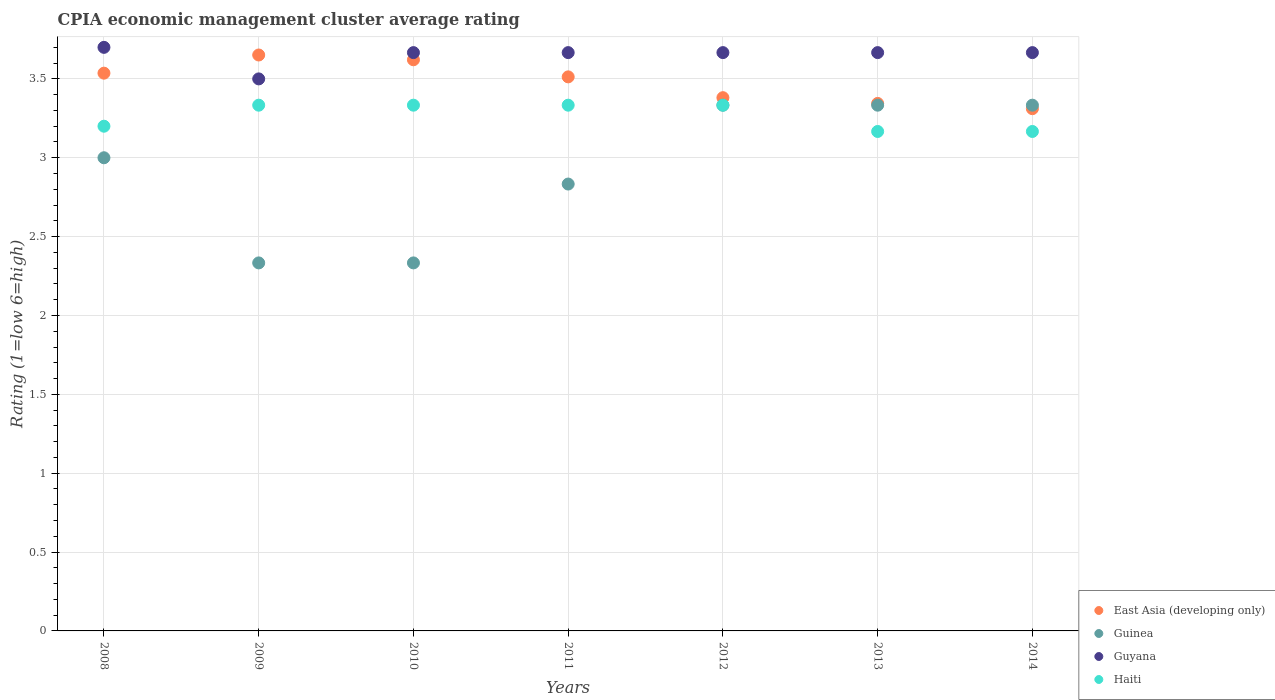What is the CPIA rating in Guyana in 2010?
Your response must be concise. 3.67. Across all years, what is the maximum CPIA rating in East Asia (developing only)?
Provide a succinct answer. 3.65. Across all years, what is the minimum CPIA rating in Haiti?
Give a very brief answer. 3.17. In which year was the CPIA rating in Haiti minimum?
Keep it short and to the point. 2013. What is the total CPIA rating in Guinea in the graph?
Provide a short and direct response. 20.5. What is the difference between the CPIA rating in Guyana in 2008 and that in 2011?
Make the answer very short. 0.03. What is the difference between the CPIA rating in Guinea in 2011 and the CPIA rating in East Asia (developing only) in 2012?
Your answer should be very brief. -0.55. What is the average CPIA rating in East Asia (developing only) per year?
Provide a short and direct response. 3.48. In the year 2008, what is the difference between the CPIA rating in Guyana and CPIA rating in East Asia (developing only)?
Offer a very short reply. 0.16. What is the ratio of the CPIA rating in East Asia (developing only) in 2008 to that in 2011?
Make the answer very short. 1.01. What is the difference between the highest and the second highest CPIA rating in Guyana?
Your response must be concise. 0.03. What is the difference between the highest and the lowest CPIA rating in East Asia (developing only)?
Provide a short and direct response. 0.34. In how many years, is the CPIA rating in Guyana greater than the average CPIA rating in Guyana taken over all years?
Ensure brevity in your answer.  6. Is the CPIA rating in Haiti strictly less than the CPIA rating in East Asia (developing only) over the years?
Your response must be concise. Yes. How many dotlines are there?
Provide a succinct answer. 4. How many years are there in the graph?
Make the answer very short. 7. What is the difference between two consecutive major ticks on the Y-axis?
Offer a terse response. 0.5. Does the graph contain any zero values?
Keep it short and to the point. No. Where does the legend appear in the graph?
Provide a short and direct response. Bottom right. How many legend labels are there?
Offer a very short reply. 4. How are the legend labels stacked?
Offer a terse response. Vertical. What is the title of the graph?
Your response must be concise. CPIA economic management cluster average rating. What is the label or title of the X-axis?
Give a very brief answer. Years. What is the label or title of the Y-axis?
Your response must be concise. Rating (1=low 6=high). What is the Rating (1=low 6=high) of East Asia (developing only) in 2008?
Make the answer very short. 3.54. What is the Rating (1=low 6=high) in Guinea in 2008?
Give a very brief answer. 3. What is the Rating (1=low 6=high) in East Asia (developing only) in 2009?
Make the answer very short. 3.65. What is the Rating (1=low 6=high) in Guinea in 2009?
Your answer should be compact. 2.33. What is the Rating (1=low 6=high) in Haiti in 2009?
Provide a short and direct response. 3.33. What is the Rating (1=low 6=high) of East Asia (developing only) in 2010?
Keep it short and to the point. 3.62. What is the Rating (1=low 6=high) in Guinea in 2010?
Provide a short and direct response. 2.33. What is the Rating (1=low 6=high) in Guyana in 2010?
Offer a terse response. 3.67. What is the Rating (1=low 6=high) of Haiti in 2010?
Offer a terse response. 3.33. What is the Rating (1=low 6=high) of East Asia (developing only) in 2011?
Provide a short and direct response. 3.51. What is the Rating (1=low 6=high) in Guinea in 2011?
Your response must be concise. 2.83. What is the Rating (1=low 6=high) in Guyana in 2011?
Ensure brevity in your answer.  3.67. What is the Rating (1=low 6=high) in Haiti in 2011?
Provide a short and direct response. 3.33. What is the Rating (1=low 6=high) in East Asia (developing only) in 2012?
Your answer should be compact. 3.38. What is the Rating (1=low 6=high) of Guinea in 2012?
Offer a very short reply. 3.33. What is the Rating (1=low 6=high) of Guyana in 2012?
Give a very brief answer. 3.67. What is the Rating (1=low 6=high) of Haiti in 2012?
Provide a succinct answer. 3.33. What is the Rating (1=low 6=high) of East Asia (developing only) in 2013?
Your answer should be compact. 3.34. What is the Rating (1=low 6=high) in Guinea in 2013?
Give a very brief answer. 3.33. What is the Rating (1=low 6=high) in Guyana in 2013?
Your answer should be very brief. 3.67. What is the Rating (1=low 6=high) of Haiti in 2013?
Your answer should be compact. 3.17. What is the Rating (1=low 6=high) in East Asia (developing only) in 2014?
Keep it short and to the point. 3.31. What is the Rating (1=low 6=high) of Guinea in 2014?
Your answer should be very brief. 3.33. What is the Rating (1=low 6=high) in Guyana in 2014?
Your answer should be very brief. 3.67. What is the Rating (1=low 6=high) of Haiti in 2014?
Your answer should be compact. 3.17. Across all years, what is the maximum Rating (1=low 6=high) of East Asia (developing only)?
Offer a very short reply. 3.65. Across all years, what is the maximum Rating (1=low 6=high) in Guinea?
Provide a succinct answer. 3.33. Across all years, what is the maximum Rating (1=low 6=high) in Guyana?
Provide a short and direct response. 3.7. Across all years, what is the maximum Rating (1=low 6=high) of Haiti?
Keep it short and to the point. 3.33. Across all years, what is the minimum Rating (1=low 6=high) in East Asia (developing only)?
Offer a terse response. 3.31. Across all years, what is the minimum Rating (1=low 6=high) of Guinea?
Keep it short and to the point. 2.33. Across all years, what is the minimum Rating (1=low 6=high) of Haiti?
Provide a succinct answer. 3.17. What is the total Rating (1=low 6=high) of East Asia (developing only) in the graph?
Give a very brief answer. 24.36. What is the total Rating (1=low 6=high) in Guyana in the graph?
Make the answer very short. 25.53. What is the total Rating (1=low 6=high) of Haiti in the graph?
Offer a terse response. 22.87. What is the difference between the Rating (1=low 6=high) of East Asia (developing only) in 2008 and that in 2009?
Provide a succinct answer. -0.12. What is the difference between the Rating (1=low 6=high) in Guinea in 2008 and that in 2009?
Give a very brief answer. 0.67. What is the difference between the Rating (1=low 6=high) of Guyana in 2008 and that in 2009?
Provide a short and direct response. 0.2. What is the difference between the Rating (1=low 6=high) in Haiti in 2008 and that in 2009?
Give a very brief answer. -0.13. What is the difference between the Rating (1=low 6=high) of East Asia (developing only) in 2008 and that in 2010?
Ensure brevity in your answer.  -0.08. What is the difference between the Rating (1=low 6=high) of Guinea in 2008 and that in 2010?
Provide a short and direct response. 0.67. What is the difference between the Rating (1=low 6=high) in Haiti in 2008 and that in 2010?
Your response must be concise. -0.13. What is the difference between the Rating (1=low 6=high) of East Asia (developing only) in 2008 and that in 2011?
Offer a terse response. 0.02. What is the difference between the Rating (1=low 6=high) in Haiti in 2008 and that in 2011?
Offer a very short reply. -0.13. What is the difference between the Rating (1=low 6=high) in East Asia (developing only) in 2008 and that in 2012?
Provide a succinct answer. 0.16. What is the difference between the Rating (1=low 6=high) of Guinea in 2008 and that in 2012?
Provide a short and direct response. -0.33. What is the difference between the Rating (1=low 6=high) in Haiti in 2008 and that in 2012?
Provide a succinct answer. -0.13. What is the difference between the Rating (1=low 6=high) of East Asia (developing only) in 2008 and that in 2013?
Your answer should be compact. 0.19. What is the difference between the Rating (1=low 6=high) of East Asia (developing only) in 2008 and that in 2014?
Keep it short and to the point. 0.23. What is the difference between the Rating (1=low 6=high) of Guyana in 2008 and that in 2014?
Your answer should be very brief. 0.03. What is the difference between the Rating (1=low 6=high) in Haiti in 2008 and that in 2014?
Ensure brevity in your answer.  0.03. What is the difference between the Rating (1=low 6=high) of East Asia (developing only) in 2009 and that in 2010?
Your answer should be very brief. 0.03. What is the difference between the Rating (1=low 6=high) of Guyana in 2009 and that in 2010?
Make the answer very short. -0.17. What is the difference between the Rating (1=low 6=high) of East Asia (developing only) in 2009 and that in 2011?
Keep it short and to the point. 0.14. What is the difference between the Rating (1=low 6=high) of Guinea in 2009 and that in 2011?
Your answer should be very brief. -0.5. What is the difference between the Rating (1=low 6=high) of East Asia (developing only) in 2009 and that in 2012?
Your answer should be compact. 0.27. What is the difference between the Rating (1=low 6=high) of Haiti in 2009 and that in 2012?
Ensure brevity in your answer.  0. What is the difference between the Rating (1=low 6=high) in East Asia (developing only) in 2009 and that in 2013?
Provide a short and direct response. 0.31. What is the difference between the Rating (1=low 6=high) of Guinea in 2009 and that in 2013?
Offer a very short reply. -1. What is the difference between the Rating (1=low 6=high) of Guyana in 2009 and that in 2013?
Your answer should be compact. -0.17. What is the difference between the Rating (1=low 6=high) of East Asia (developing only) in 2009 and that in 2014?
Offer a very short reply. 0.34. What is the difference between the Rating (1=low 6=high) of Guinea in 2009 and that in 2014?
Make the answer very short. -1. What is the difference between the Rating (1=low 6=high) in Haiti in 2009 and that in 2014?
Offer a very short reply. 0.17. What is the difference between the Rating (1=low 6=high) of East Asia (developing only) in 2010 and that in 2011?
Provide a succinct answer. 0.11. What is the difference between the Rating (1=low 6=high) in Guinea in 2010 and that in 2011?
Provide a short and direct response. -0.5. What is the difference between the Rating (1=low 6=high) of East Asia (developing only) in 2010 and that in 2012?
Provide a succinct answer. 0.24. What is the difference between the Rating (1=low 6=high) of Guinea in 2010 and that in 2012?
Your answer should be very brief. -1. What is the difference between the Rating (1=low 6=high) in Haiti in 2010 and that in 2012?
Offer a terse response. 0. What is the difference between the Rating (1=low 6=high) of East Asia (developing only) in 2010 and that in 2013?
Your response must be concise. 0.28. What is the difference between the Rating (1=low 6=high) of Guinea in 2010 and that in 2013?
Offer a very short reply. -1. What is the difference between the Rating (1=low 6=high) of Guyana in 2010 and that in 2013?
Your response must be concise. 0. What is the difference between the Rating (1=low 6=high) of Haiti in 2010 and that in 2013?
Your answer should be compact. 0.17. What is the difference between the Rating (1=low 6=high) in East Asia (developing only) in 2010 and that in 2014?
Your response must be concise. 0.31. What is the difference between the Rating (1=low 6=high) of Guinea in 2010 and that in 2014?
Your response must be concise. -1. What is the difference between the Rating (1=low 6=high) in Guyana in 2010 and that in 2014?
Provide a short and direct response. -0. What is the difference between the Rating (1=low 6=high) in Haiti in 2010 and that in 2014?
Offer a very short reply. 0.17. What is the difference between the Rating (1=low 6=high) of East Asia (developing only) in 2011 and that in 2012?
Offer a terse response. 0.13. What is the difference between the Rating (1=low 6=high) of Guinea in 2011 and that in 2012?
Keep it short and to the point. -0.5. What is the difference between the Rating (1=low 6=high) in Haiti in 2011 and that in 2012?
Offer a terse response. 0. What is the difference between the Rating (1=low 6=high) of East Asia (developing only) in 2011 and that in 2013?
Your answer should be very brief. 0.17. What is the difference between the Rating (1=low 6=high) of East Asia (developing only) in 2011 and that in 2014?
Your answer should be compact. 0.2. What is the difference between the Rating (1=low 6=high) of Guinea in 2011 and that in 2014?
Ensure brevity in your answer.  -0.5. What is the difference between the Rating (1=low 6=high) of Guyana in 2011 and that in 2014?
Your answer should be very brief. -0. What is the difference between the Rating (1=low 6=high) in Haiti in 2011 and that in 2014?
Provide a short and direct response. 0.17. What is the difference between the Rating (1=low 6=high) of East Asia (developing only) in 2012 and that in 2013?
Your answer should be compact. 0.04. What is the difference between the Rating (1=low 6=high) of Guyana in 2012 and that in 2013?
Provide a succinct answer. 0. What is the difference between the Rating (1=low 6=high) in Haiti in 2012 and that in 2013?
Give a very brief answer. 0.17. What is the difference between the Rating (1=low 6=high) of East Asia (developing only) in 2012 and that in 2014?
Ensure brevity in your answer.  0.07. What is the difference between the Rating (1=low 6=high) of Guinea in 2012 and that in 2014?
Offer a very short reply. 0. What is the difference between the Rating (1=low 6=high) in Haiti in 2012 and that in 2014?
Your response must be concise. 0.17. What is the difference between the Rating (1=low 6=high) in East Asia (developing only) in 2013 and that in 2014?
Make the answer very short. 0.03. What is the difference between the Rating (1=low 6=high) of East Asia (developing only) in 2008 and the Rating (1=low 6=high) of Guinea in 2009?
Ensure brevity in your answer.  1.2. What is the difference between the Rating (1=low 6=high) of East Asia (developing only) in 2008 and the Rating (1=low 6=high) of Guyana in 2009?
Offer a terse response. 0.04. What is the difference between the Rating (1=low 6=high) in East Asia (developing only) in 2008 and the Rating (1=low 6=high) in Haiti in 2009?
Offer a very short reply. 0.2. What is the difference between the Rating (1=low 6=high) in Guyana in 2008 and the Rating (1=low 6=high) in Haiti in 2009?
Offer a very short reply. 0.37. What is the difference between the Rating (1=low 6=high) in East Asia (developing only) in 2008 and the Rating (1=low 6=high) in Guinea in 2010?
Keep it short and to the point. 1.2. What is the difference between the Rating (1=low 6=high) of East Asia (developing only) in 2008 and the Rating (1=low 6=high) of Guyana in 2010?
Provide a short and direct response. -0.13. What is the difference between the Rating (1=low 6=high) in East Asia (developing only) in 2008 and the Rating (1=low 6=high) in Haiti in 2010?
Your answer should be compact. 0.2. What is the difference between the Rating (1=low 6=high) in Guinea in 2008 and the Rating (1=low 6=high) in Guyana in 2010?
Offer a terse response. -0.67. What is the difference between the Rating (1=low 6=high) in Guinea in 2008 and the Rating (1=low 6=high) in Haiti in 2010?
Offer a very short reply. -0.33. What is the difference between the Rating (1=low 6=high) of Guyana in 2008 and the Rating (1=low 6=high) of Haiti in 2010?
Keep it short and to the point. 0.37. What is the difference between the Rating (1=low 6=high) of East Asia (developing only) in 2008 and the Rating (1=low 6=high) of Guinea in 2011?
Give a very brief answer. 0.7. What is the difference between the Rating (1=low 6=high) of East Asia (developing only) in 2008 and the Rating (1=low 6=high) of Guyana in 2011?
Offer a terse response. -0.13. What is the difference between the Rating (1=low 6=high) of East Asia (developing only) in 2008 and the Rating (1=low 6=high) of Haiti in 2011?
Offer a very short reply. 0.2. What is the difference between the Rating (1=low 6=high) in Guinea in 2008 and the Rating (1=low 6=high) in Guyana in 2011?
Provide a short and direct response. -0.67. What is the difference between the Rating (1=low 6=high) in Guyana in 2008 and the Rating (1=low 6=high) in Haiti in 2011?
Your answer should be very brief. 0.37. What is the difference between the Rating (1=low 6=high) of East Asia (developing only) in 2008 and the Rating (1=low 6=high) of Guinea in 2012?
Provide a succinct answer. 0.2. What is the difference between the Rating (1=low 6=high) in East Asia (developing only) in 2008 and the Rating (1=low 6=high) in Guyana in 2012?
Ensure brevity in your answer.  -0.13. What is the difference between the Rating (1=low 6=high) in East Asia (developing only) in 2008 and the Rating (1=low 6=high) in Haiti in 2012?
Make the answer very short. 0.2. What is the difference between the Rating (1=low 6=high) of Guyana in 2008 and the Rating (1=low 6=high) of Haiti in 2012?
Ensure brevity in your answer.  0.37. What is the difference between the Rating (1=low 6=high) in East Asia (developing only) in 2008 and the Rating (1=low 6=high) in Guinea in 2013?
Your answer should be compact. 0.2. What is the difference between the Rating (1=low 6=high) of East Asia (developing only) in 2008 and the Rating (1=low 6=high) of Guyana in 2013?
Offer a terse response. -0.13. What is the difference between the Rating (1=low 6=high) in East Asia (developing only) in 2008 and the Rating (1=low 6=high) in Haiti in 2013?
Ensure brevity in your answer.  0.37. What is the difference between the Rating (1=low 6=high) of Guinea in 2008 and the Rating (1=low 6=high) of Haiti in 2013?
Offer a terse response. -0.17. What is the difference between the Rating (1=low 6=high) of Guyana in 2008 and the Rating (1=low 6=high) of Haiti in 2013?
Your answer should be very brief. 0.53. What is the difference between the Rating (1=low 6=high) of East Asia (developing only) in 2008 and the Rating (1=low 6=high) of Guinea in 2014?
Offer a very short reply. 0.2. What is the difference between the Rating (1=low 6=high) in East Asia (developing only) in 2008 and the Rating (1=low 6=high) in Guyana in 2014?
Your response must be concise. -0.13. What is the difference between the Rating (1=low 6=high) of East Asia (developing only) in 2008 and the Rating (1=low 6=high) of Haiti in 2014?
Keep it short and to the point. 0.37. What is the difference between the Rating (1=low 6=high) in Guinea in 2008 and the Rating (1=low 6=high) in Haiti in 2014?
Keep it short and to the point. -0.17. What is the difference between the Rating (1=low 6=high) of Guyana in 2008 and the Rating (1=low 6=high) of Haiti in 2014?
Your answer should be very brief. 0.53. What is the difference between the Rating (1=low 6=high) of East Asia (developing only) in 2009 and the Rating (1=low 6=high) of Guinea in 2010?
Provide a short and direct response. 1.32. What is the difference between the Rating (1=low 6=high) of East Asia (developing only) in 2009 and the Rating (1=low 6=high) of Guyana in 2010?
Provide a succinct answer. -0.02. What is the difference between the Rating (1=low 6=high) of East Asia (developing only) in 2009 and the Rating (1=low 6=high) of Haiti in 2010?
Keep it short and to the point. 0.32. What is the difference between the Rating (1=low 6=high) in Guinea in 2009 and the Rating (1=low 6=high) in Guyana in 2010?
Provide a short and direct response. -1.33. What is the difference between the Rating (1=low 6=high) of East Asia (developing only) in 2009 and the Rating (1=low 6=high) of Guinea in 2011?
Make the answer very short. 0.82. What is the difference between the Rating (1=low 6=high) of East Asia (developing only) in 2009 and the Rating (1=low 6=high) of Guyana in 2011?
Make the answer very short. -0.02. What is the difference between the Rating (1=low 6=high) in East Asia (developing only) in 2009 and the Rating (1=low 6=high) in Haiti in 2011?
Make the answer very short. 0.32. What is the difference between the Rating (1=low 6=high) in Guinea in 2009 and the Rating (1=low 6=high) in Guyana in 2011?
Your response must be concise. -1.33. What is the difference between the Rating (1=low 6=high) in East Asia (developing only) in 2009 and the Rating (1=low 6=high) in Guinea in 2012?
Your answer should be very brief. 0.32. What is the difference between the Rating (1=low 6=high) in East Asia (developing only) in 2009 and the Rating (1=low 6=high) in Guyana in 2012?
Your answer should be compact. -0.02. What is the difference between the Rating (1=low 6=high) in East Asia (developing only) in 2009 and the Rating (1=low 6=high) in Haiti in 2012?
Keep it short and to the point. 0.32. What is the difference between the Rating (1=low 6=high) in Guinea in 2009 and the Rating (1=low 6=high) in Guyana in 2012?
Your answer should be compact. -1.33. What is the difference between the Rating (1=low 6=high) in East Asia (developing only) in 2009 and the Rating (1=low 6=high) in Guinea in 2013?
Your response must be concise. 0.32. What is the difference between the Rating (1=low 6=high) of East Asia (developing only) in 2009 and the Rating (1=low 6=high) of Guyana in 2013?
Keep it short and to the point. -0.02. What is the difference between the Rating (1=low 6=high) of East Asia (developing only) in 2009 and the Rating (1=low 6=high) of Haiti in 2013?
Give a very brief answer. 0.48. What is the difference between the Rating (1=low 6=high) in Guinea in 2009 and the Rating (1=low 6=high) in Guyana in 2013?
Offer a very short reply. -1.33. What is the difference between the Rating (1=low 6=high) of Guyana in 2009 and the Rating (1=low 6=high) of Haiti in 2013?
Ensure brevity in your answer.  0.33. What is the difference between the Rating (1=low 6=high) of East Asia (developing only) in 2009 and the Rating (1=low 6=high) of Guinea in 2014?
Provide a short and direct response. 0.32. What is the difference between the Rating (1=low 6=high) in East Asia (developing only) in 2009 and the Rating (1=low 6=high) in Guyana in 2014?
Keep it short and to the point. -0.02. What is the difference between the Rating (1=low 6=high) in East Asia (developing only) in 2009 and the Rating (1=low 6=high) in Haiti in 2014?
Your answer should be very brief. 0.48. What is the difference between the Rating (1=low 6=high) of Guinea in 2009 and the Rating (1=low 6=high) of Guyana in 2014?
Make the answer very short. -1.33. What is the difference between the Rating (1=low 6=high) of Guyana in 2009 and the Rating (1=low 6=high) of Haiti in 2014?
Your response must be concise. 0.33. What is the difference between the Rating (1=low 6=high) in East Asia (developing only) in 2010 and the Rating (1=low 6=high) in Guinea in 2011?
Make the answer very short. 0.79. What is the difference between the Rating (1=low 6=high) of East Asia (developing only) in 2010 and the Rating (1=low 6=high) of Guyana in 2011?
Offer a terse response. -0.05. What is the difference between the Rating (1=low 6=high) in East Asia (developing only) in 2010 and the Rating (1=low 6=high) in Haiti in 2011?
Offer a very short reply. 0.29. What is the difference between the Rating (1=low 6=high) in Guinea in 2010 and the Rating (1=low 6=high) in Guyana in 2011?
Your response must be concise. -1.33. What is the difference between the Rating (1=low 6=high) of Guinea in 2010 and the Rating (1=low 6=high) of Haiti in 2011?
Offer a very short reply. -1. What is the difference between the Rating (1=low 6=high) of East Asia (developing only) in 2010 and the Rating (1=low 6=high) of Guinea in 2012?
Provide a succinct answer. 0.29. What is the difference between the Rating (1=low 6=high) in East Asia (developing only) in 2010 and the Rating (1=low 6=high) in Guyana in 2012?
Your answer should be very brief. -0.05. What is the difference between the Rating (1=low 6=high) in East Asia (developing only) in 2010 and the Rating (1=low 6=high) in Haiti in 2012?
Provide a short and direct response. 0.29. What is the difference between the Rating (1=low 6=high) of Guinea in 2010 and the Rating (1=low 6=high) of Guyana in 2012?
Keep it short and to the point. -1.33. What is the difference between the Rating (1=low 6=high) of Guyana in 2010 and the Rating (1=low 6=high) of Haiti in 2012?
Give a very brief answer. 0.33. What is the difference between the Rating (1=low 6=high) in East Asia (developing only) in 2010 and the Rating (1=low 6=high) in Guinea in 2013?
Your response must be concise. 0.29. What is the difference between the Rating (1=low 6=high) in East Asia (developing only) in 2010 and the Rating (1=low 6=high) in Guyana in 2013?
Your answer should be compact. -0.05. What is the difference between the Rating (1=low 6=high) in East Asia (developing only) in 2010 and the Rating (1=low 6=high) in Haiti in 2013?
Make the answer very short. 0.45. What is the difference between the Rating (1=low 6=high) in Guinea in 2010 and the Rating (1=low 6=high) in Guyana in 2013?
Give a very brief answer. -1.33. What is the difference between the Rating (1=low 6=high) of Guyana in 2010 and the Rating (1=low 6=high) of Haiti in 2013?
Keep it short and to the point. 0.5. What is the difference between the Rating (1=low 6=high) in East Asia (developing only) in 2010 and the Rating (1=low 6=high) in Guinea in 2014?
Offer a terse response. 0.29. What is the difference between the Rating (1=low 6=high) of East Asia (developing only) in 2010 and the Rating (1=low 6=high) of Guyana in 2014?
Offer a terse response. -0.05. What is the difference between the Rating (1=low 6=high) of East Asia (developing only) in 2010 and the Rating (1=low 6=high) of Haiti in 2014?
Ensure brevity in your answer.  0.45. What is the difference between the Rating (1=low 6=high) of Guinea in 2010 and the Rating (1=low 6=high) of Guyana in 2014?
Provide a succinct answer. -1.33. What is the difference between the Rating (1=low 6=high) of East Asia (developing only) in 2011 and the Rating (1=low 6=high) of Guinea in 2012?
Provide a short and direct response. 0.18. What is the difference between the Rating (1=low 6=high) in East Asia (developing only) in 2011 and the Rating (1=low 6=high) in Guyana in 2012?
Make the answer very short. -0.15. What is the difference between the Rating (1=low 6=high) in East Asia (developing only) in 2011 and the Rating (1=low 6=high) in Haiti in 2012?
Your response must be concise. 0.18. What is the difference between the Rating (1=low 6=high) in Guinea in 2011 and the Rating (1=low 6=high) in Haiti in 2012?
Provide a succinct answer. -0.5. What is the difference between the Rating (1=low 6=high) in East Asia (developing only) in 2011 and the Rating (1=low 6=high) in Guinea in 2013?
Your answer should be very brief. 0.18. What is the difference between the Rating (1=low 6=high) in East Asia (developing only) in 2011 and the Rating (1=low 6=high) in Guyana in 2013?
Offer a very short reply. -0.15. What is the difference between the Rating (1=low 6=high) in East Asia (developing only) in 2011 and the Rating (1=low 6=high) in Haiti in 2013?
Your answer should be very brief. 0.35. What is the difference between the Rating (1=low 6=high) of Guinea in 2011 and the Rating (1=low 6=high) of Haiti in 2013?
Your answer should be very brief. -0.33. What is the difference between the Rating (1=low 6=high) in Guyana in 2011 and the Rating (1=low 6=high) in Haiti in 2013?
Your answer should be very brief. 0.5. What is the difference between the Rating (1=low 6=high) in East Asia (developing only) in 2011 and the Rating (1=low 6=high) in Guinea in 2014?
Offer a terse response. 0.18. What is the difference between the Rating (1=low 6=high) in East Asia (developing only) in 2011 and the Rating (1=low 6=high) in Guyana in 2014?
Your response must be concise. -0.15. What is the difference between the Rating (1=low 6=high) in East Asia (developing only) in 2011 and the Rating (1=low 6=high) in Haiti in 2014?
Your answer should be very brief. 0.35. What is the difference between the Rating (1=low 6=high) of Guyana in 2011 and the Rating (1=low 6=high) of Haiti in 2014?
Give a very brief answer. 0.5. What is the difference between the Rating (1=low 6=high) in East Asia (developing only) in 2012 and the Rating (1=low 6=high) in Guinea in 2013?
Your response must be concise. 0.05. What is the difference between the Rating (1=low 6=high) of East Asia (developing only) in 2012 and the Rating (1=low 6=high) of Guyana in 2013?
Provide a succinct answer. -0.29. What is the difference between the Rating (1=low 6=high) of East Asia (developing only) in 2012 and the Rating (1=low 6=high) of Haiti in 2013?
Give a very brief answer. 0.21. What is the difference between the Rating (1=low 6=high) of Guinea in 2012 and the Rating (1=low 6=high) of Haiti in 2013?
Keep it short and to the point. 0.17. What is the difference between the Rating (1=low 6=high) of East Asia (developing only) in 2012 and the Rating (1=low 6=high) of Guinea in 2014?
Give a very brief answer. 0.05. What is the difference between the Rating (1=low 6=high) of East Asia (developing only) in 2012 and the Rating (1=low 6=high) of Guyana in 2014?
Your answer should be very brief. -0.29. What is the difference between the Rating (1=low 6=high) of East Asia (developing only) in 2012 and the Rating (1=low 6=high) of Haiti in 2014?
Give a very brief answer. 0.21. What is the difference between the Rating (1=low 6=high) of Guinea in 2012 and the Rating (1=low 6=high) of Guyana in 2014?
Provide a succinct answer. -0.33. What is the difference between the Rating (1=low 6=high) in Guyana in 2012 and the Rating (1=low 6=high) in Haiti in 2014?
Provide a succinct answer. 0.5. What is the difference between the Rating (1=low 6=high) of East Asia (developing only) in 2013 and the Rating (1=low 6=high) of Guinea in 2014?
Offer a very short reply. 0.01. What is the difference between the Rating (1=low 6=high) in East Asia (developing only) in 2013 and the Rating (1=low 6=high) in Guyana in 2014?
Offer a very short reply. -0.32. What is the difference between the Rating (1=low 6=high) of East Asia (developing only) in 2013 and the Rating (1=low 6=high) of Haiti in 2014?
Provide a short and direct response. 0.18. What is the average Rating (1=low 6=high) in East Asia (developing only) per year?
Provide a succinct answer. 3.48. What is the average Rating (1=low 6=high) in Guinea per year?
Give a very brief answer. 2.93. What is the average Rating (1=low 6=high) in Guyana per year?
Your answer should be compact. 3.65. What is the average Rating (1=low 6=high) of Haiti per year?
Offer a terse response. 3.27. In the year 2008, what is the difference between the Rating (1=low 6=high) of East Asia (developing only) and Rating (1=low 6=high) of Guinea?
Offer a very short reply. 0.54. In the year 2008, what is the difference between the Rating (1=low 6=high) of East Asia (developing only) and Rating (1=low 6=high) of Guyana?
Your answer should be compact. -0.16. In the year 2008, what is the difference between the Rating (1=low 6=high) of East Asia (developing only) and Rating (1=low 6=high) of Haiti?
Provide a succinct answer. 0.34. In the year 2008, what is the difference between the Rating (1=low 6=high) of Guinea and Rating (1=low 6=high) of Haiti?
Your answer should be compact. -0.2. In the year 2008, what is the difference between the Rating (1=low 6=high) in Guyana and Rating (1=low 6=high) in Haiti?
Provide a short and direct response. 0.5. In the year 2009, what is the difference between the Rating (1=low 6=high) of East Asia (developing only) and Rating (1=low 6=high) of Guinea?
Provide a succinct answer. 1.32. In the year 2009, what is the difference between the Rating (1=low 6=high) of East Asia (developing only) and Rating (1=low 6=high) of Guyana?
Provide a succinct answer. 0.15. In the year 2009, what is the difference between the Rating (1=low 6=high) in East Asia (developing only) and Rating (1=low 6=high) in Haiti?
Offer a very short reply. 0.32. In the year 2009, what is the difference between the Rating (1=low 6=high) of Guinea and Rating (1=low 6=high) of Guyana?
Your answer should be very brief. -1.17. In the year 2009, what is the difference between the Rating (1=low 6=high) of Guyana and Rating (1=low 6=high) of Haiti?
Your response must be concise. 0.17. In the year 2010, what is the difference between the Rating (1=low 6=high) of East Asia (developing only) and Rating (1=low 6=high) of Guinea?
Provide a short and direct response. 1.29. In the year 2010, what is the difference between the Rating (1=low 6=high) of East Asia (developing only) and Rating (1=low 6=high) of Guyana?
Ensure brevity in your answer.  -0.05. In the year 2010, what is the difference between the Rating (1=low 6=high) of East Asia (developing only) and Rating (1=low 6=high) of Haiti?
Give a very brief answer. 0.29. In the year 2010, what is the difference between the Rating (1=low 6=high) in Guinea and Rating (1=low 6=high) in Guyana?
Provide a succinct answer. -1.33. In the year 2011, what is the difference between the Rating (1=low 6=high) of East Asia (developing only) and Rating (1=low 6=high) of Guinea?
Your answer should be compact. 0.68. In the year 2011, what is the difference between the Rating (1=low 6=high) in East Asia (developing only) and Rating (1=low 6=high) in Guyana?
Your response must be concise. -0.15. In the year 2011, what is the difference between the Rating (1=low 6=high) of East Asia (developing only) and Rating (1=low 6=high) of Haiti?
Offer a very short reply. 0.18. In the year 2011, what is the difference between the Rating (1=low 6=high) in Guinea and Rating (1=low 6=high) in Haiti?
Your answer should be compact. -0.5. In the year 2011, what is the difference between the Rating (1=low 6=high) in Guyana and Rating (1=low 6=high) in Haiti?
Offer a terse response. 0.33. In the year 2012, what is the difference between the Rating (1=low 6=high) of East Asia (developing only) and Rating (1=low 6=high) of Guinea?
Offer a terse response. 0.05. In the year 2012, what is the difference between the Rating (1=low 6=high) of East Asia (developing only) and Rating (1=low 6=high) of Guyana?
Your answer should be very brief. -0.29. In the year 2012, what is the difference between the Rating (1=low 6=high) in East Asia (developing only) and Rating (1=low 6=high) in Haiti?
Your response must be concise. 0.05. In the year 2012, what is the difference between the Rating (1=low 6=high) of Guinea and Rating (1=low 6=high) of Haiti?
Give a very brief answer. 0. In the year 2013, what is the difference between the Rating (1=low 6=high) in East Asia (developing only) and Rating (1=low 6=high) in Guinea?
Ensure brevity in your answer.  0.01. In the year 2013, what is the difference between the Rating (1=low 6=high) in East Asia (developing only) and Rating (1=low 6=high) in Guyana?
Your response must be concise. -0.32. In the year 2013, what is the difference between the Rating (1=low 6=high) in East Asia (developing only) and Rating (1=low 6=high) in Haiti?
Make the answer very short. 0.18. In the year 2013, what is the difference between the Rating (1=low 6=high) in Guinea and Rating (1=low 6=high) in Guyana?
Your answer should be very brief. -0.33. In the year 2013, what is the difference between the Rating (1=low 6=high) of Guinea and Rating (1=low 6=high) of Haiti?
Offer a very short reply. 0.17. In the year 2014, what is the difference between the Rating (1=low 6=high) of East Asia (developing only) and Rating (1=low 6=high) of Guinea?
Offer a very short reply. -0.02. In the year 2014, what is the difference between the Rating (1=low 6=high) in East Asia (developing only) and Rating (1=low 6=high) in Guyana?
Make the answer very short. -0.36. In the year 2014, what is the difference between the Rating (1=low 6=high) in East Asia (developing only) and Rating (1=low 6=high) in Haiti?
Offer a terse response. 0.14. In the year 2014, what is the difference between the Rating (1=low 6=high) in Guinea and Rating (1=low 6=high) in Guyana?
Provide a succinct answer. -0.33. In the year 2014, what is the difference between the Rating (1=low 6=high) of Guyana and Rating (1=low 6=high) of Haiti?
Your answer should be very brief. 0.5. What is the ratio of the Rating (1=low 6=high) of East Asia (developing only) in 2008 to that in 2009?
Your answer should be compact. 0.97. What is the ratio of the Rating (1=low 6=high) of Guinea in 2008 to that in 2009?
Your response must be concise. 1.29. What is the ratio of the Rating (1=low 6=high) of Guyana in 2008 to that in 2009?
Your answer should be compact. 1.06. What is the ratio of the Rating (1=low 6=high) of East Asia (developing only) in 2008 to that in 2010?
Provide a succinct answer. 0.98. What is the ratio of the Rating (1=low 6=high) in Guyana in 2008 to that in 2010?
Offer a very short reply. 1.01. What is the ratio of the Rating (1=low 6=high) in Haiti in 2008 to that in 2010?
Your response must be concise. 0.96. What is the ratio of the Rating (1=low 6=high) of Guinea in 2008 to that in 2011?
Provide a succinct answer. 1.06. What is the ratio of the Rating (1=low 6=high) of Guyana in 2008 to that in 2011?
Offer a terse response. 1.01. What is the ratio of the Rating (1=low 6=high) of East Asia (developing only) in 2008 to that in 2012?
Ensure brevity in your answer.  1.05. What is the ratio of the Rating (1=low 6=high) of Guinea in 2008 to that in 2012?
Your answer should be compact. 0.9. What is the ratio of the Rating (1=low 6=high) in Guyana in 2008 to that in 2012?
Keep it short and to the point. 1.01. What is the ratio of the Rating (1=low 6=high) in East Asia (developing only) in 2008 to that in 2013?
Provide a succinct answer. 1.06. What is the ratio of the Rating (1=low 6=high) of Guyana in 2008 to that in 2013?
Offer a very short reply. 1.01. What is the ratio of the Rating (1=low 6=high) of Haiti in 2008 to that in 2013?
Ensure brevity in your answer.  1.01. What is the ratio of the Rating (1=low 6=high) of East Asia (developing only) in 2008 to that in 2014?
Provide a short and direct response. 1.07. What is the ratio of the Rating (1=low 6=high) in Guinea in 2008 to that in 2014?
Your answer should be very brief. 0.9. What is the ratio of the Rating (1=low 6=high) in Guyana in 2008 to that in 2014?
Your answer should be very brief. 1.01. What is the ratio of the Rating (1=low 6=high) in Haiti in 2008 to that in 2014?
Make the answer very short. 1.01. What is the ratio of the Rating (1=low 6=high) in East Asia (developing only) in 2009 to that in 2010?
Offer a terse response. 1.01. What is the ratio of the Rating (1=low 6=high) of Guinea in 2009 to that in 2010?
Give a very brief answer. 1. What is the ratio of the Rating (1=low 6=high) in Guyana in 2009 to that in 2010?
Offer a terse response. 0.95. What is the ratio of the Rating (1=low 6=high) in Haiti in 2009 to that in 2010?
Make the answer very short. 1. What is the ratio of the Rating (1=low 6=high) in East Asia (developing only) in 2009 to that in 2011?
Keep it short and to the point. 1.04. What is the ratio of the Rating (1=low 6=high) in Guinea in 2009 to that in 2011?
Give a very brief answer. 0.82. What is the ratio of the Rating (1=low 6=high) of Guyana in 2009 to that in 2011?
Give a very brief answer. 0.95. What is the ratio of the Rating (1=low 6=high) of Haiti in 2009 to that in 2011?
Your answer should be very brief. 1. What is the ratio of the Rating (1=low 6=high) in Guyana in 2009 to that in 2012?
Provide a short and direct response. 0.95. What is the ratio of the Rating (1=low 6=high) in Haiti in 2009 to that in 2012?
Your answer should be very brief. 1. What is the ratio of the Rating (1=low 6=high) in East Asia (developing only) in 2009 to that in 2013?
Make the answer very short. 1.09. What is the ratio of the Rating (1=low 6=high) of Guyana in 2009 to that in 2013?
Offer a terse response. 0.95. What is the ratio of the Rating (1=low 6=high) of Haiti in 2009 to that in 2013?
Ensure brevity in your answer.  1.05. What is the ratio of the Rating (1=low 6=high) of East Asia (developing only) in 2009 to that in 2014?
Give a very brief answer. 1.1. What is the ratio of the Rating (1=low 6=high) in Guyana in 2009 to that in 2014?
Provide a succinct answer. 0.95. What is the ratio of the Rating (1=low 6=high) in Haiti in 2009 to that in 2014?
Give a very brief answer. 1.05. What is the ratio of the Rating (1=low 6=high) in East Asia (developing only) in 2010 to that in 2011?
Offer a terse response. 1.03. What is the ratio of the Rating (1=low 6=high) of Guinea in 2010 to that in 2011?
Offer a terse response. 0.82. What is the ratio of the Rating (1=low 6=high) of Guyana in 2010 to that in 2011?
Ensure brevity in your answer.  1. What is the ratio of the Rating (1=low 6=high) of Haiti in 2010 to that in 2011?
Your answer should be compact. 1. What is the ratio of the Rating (1=low 6=high) in East Asia (developing only) in 2010 to that in 2012?
Ensure brevity in your answer.  1.07. What is the ratio of the Rating (1=low 6=high) in Guinea in 2010 to that in 2012?
Your answer should be very brief. 0.7. What is the ratio of the Rating (1=low 6=high) of Haiti in 2010 to that in 2012?
Ensure brevity in your answer.  1. What is the ratio of the Rating (1=low 6=high) of East Asia (developing only) in 2010 to that in 2013?
Provide a short and direct response. 1.08. What is the ratio of the Rating (1=low 6=high) of Guinea in 2010 to that in 2013?
Offer a terse response. 0.7. What is the ratio of the Rating (1=low 6=high) in Haiti in 2010 to that in 2013?
Keep it short and to the point. 1.05. What is the ratio of the Rating (1=low 6=high) in East Asia (developing only) in 2010 to that in 2014?
Provide a succinct answer. 1.09. What is the ratio of the Rating (1=low 6=high) of Haiti in 2010 to that in 2014?
Give a very brief answer. 1.05. What is the ratio of the Rating (1=low 6=high) in East Asia (developing only) in 2011 to that in 2012?
Your answer should be compact. 1.04. What is the ratio of the Rating (1=low 6=high) of Guyana in 2011 to that in 2012?
Give a very brief answer. 1. What is the ratio of the Rating (1=low 6=high) in Haiti in 2011 to that in 2012?
Provide a succinct answer. 1. What is the ratio of the Rating (1=low 6=high) of East Asia (developing only) in 2011 to that in 2013?
Provide a succinct answer. 1.05. What is the ratio of the Rating (1=low 6=high) in Haiti in 2011 to that in 2013?
Ensure brevity in your answer.  1.05. What is the ratio of the Rating (1=low 6=high) in East Asia (developing only) in 2011 to that in 2014?
Make the answer very short. 1.06. What is the ratio of the Rating (1=low 6=high) in Haiti in 2011 to that in 2014?
Offer a very short reply. 1.05. What is the ratio of the Rating (1=low 6=high) of East Asia (developing only) in 2012 to that in 2013?
Your response must be concise. 1.01. What is the ratio of the Rating (1=low 6=high) of Guinea in 2012 to that in 2013?
Keep it short and to the point. 1. What is the ratio of the Rating (1=low 6=high) in Guyana in 2012 to that in 2013?
Your answer should be compact. 1. What is the ratio of the Rating (1=low 6=high) of Haiti in 2012 to that in 2013?
Ensure brevity in your answer.  1.05. What is the ratio of the Rating (1=low 6=high) in East Asia (developing only) in 2012 to that in 2014?
Your response must be concise. 1.02. What is the ratio of the Rating (1=low 6=high) of Guyana in 2012 to that in 2014?
Make the answer very short. 1. What is the ratio of the Rating (1=low 6=high) of Haiti in 2012 to that in 2014?
Your response must be concise. 1.05. What is the ratio of the Rating (1=low 6=high) of East Asia (developing only) in 2013 to that in 2014?
Keep it short and to the point. 1.01. What is the ratio of the Rating (1=low 6=high) of Guinea in 2013 to that in 2014?
Your answer should be very brief. 1. What is the difference between the highest and the second highest Rating (1=low 6=high) of East Asia (developing only)?
Keep it short and to the point. 0.03. What is the difference between the highest and the second highest Rating (1=low 6=high) in Guyana?
Your answer should be very brief. 0.03. What is the difference between the highest and the lowest Rating (1=low 6=high) in East Asia (developing only)?
Your answer should be compact. 0.34. What is the difference between the highest and the lowest Rating (1=low 6=high) of Guyana?
Your response must be concise. 0.2. 